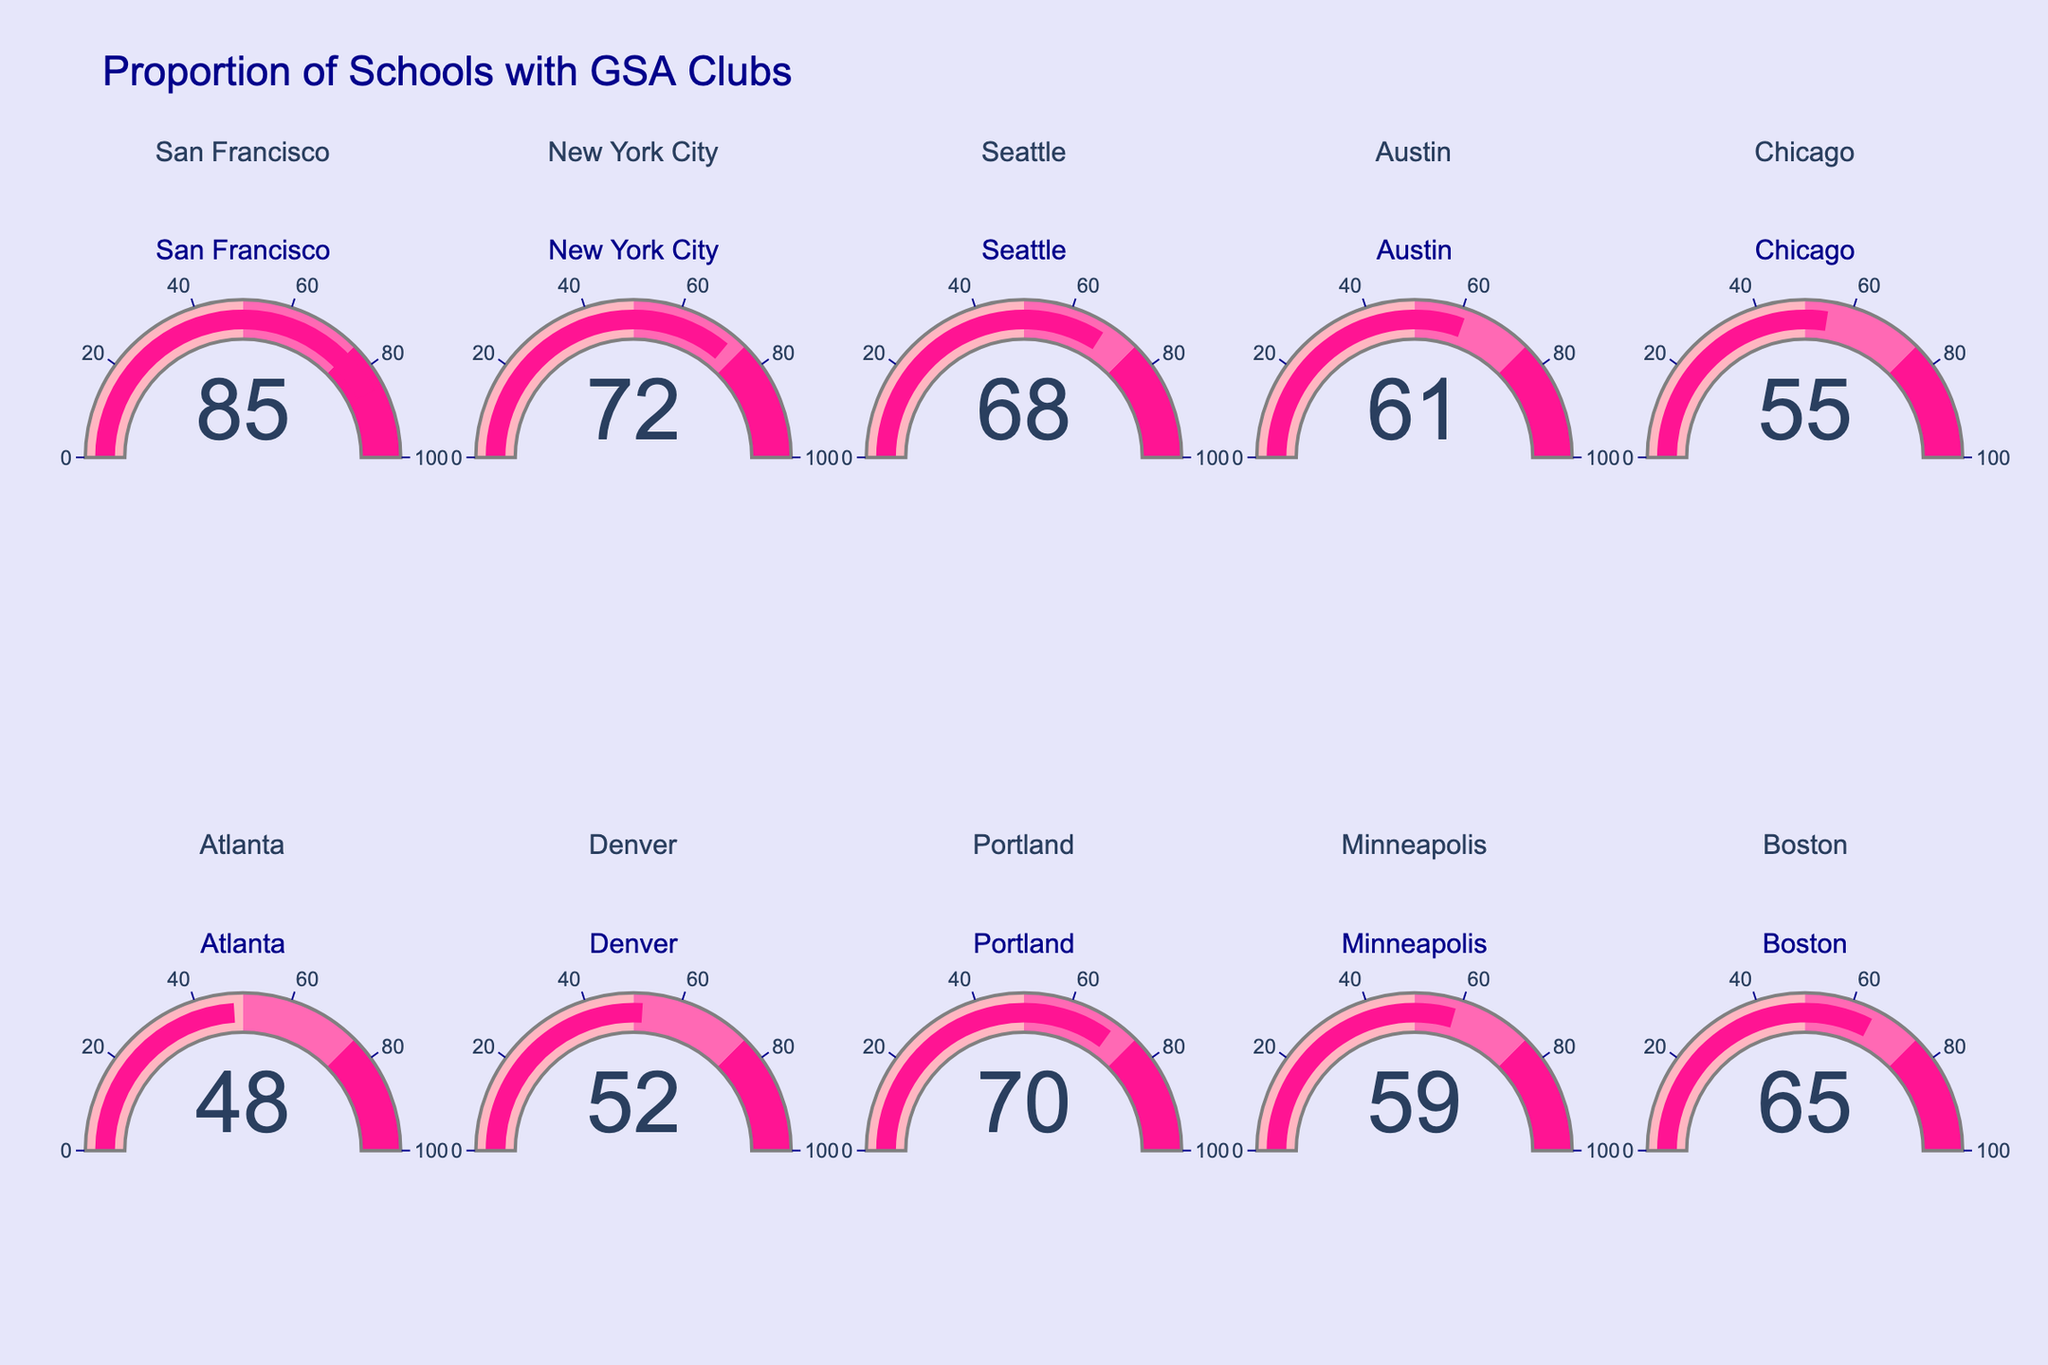Which city has the highest percentage of schools with GSA clubs? Look at all the gauges and identify the one with the highest percentage value displayed. San Francisco has the highest percentage with 85%.
Answer: San Francisco What's the lowest percentage of schools with GSA clubs, and which city does it belong to? Scan all the gauges to find the lowest percentage value. The lowest value is 48%, which belongs to Atlanta.
Answer: 48%, Atlanta What's the average percentage of schools with GSA clubs across all cities? Sum all the percentages from each gauge and divide by the number of cities (10). The sum is 85+72+68+61+55+48+52+70+59+65 = 635. The average is 635/10 = 63.5.
Answer: 63.5 How many cities have more than 60% of schools with GSA clubs? Count the number of gauges displaying values greater than 60%. The cities are San Francisco, New York City, Seattle, Portland, Boston. So, there are 5.
Answer: 5 Which cities have a percentage of schools with GSA clubs in the range 50-75%? Identify all gauges with values between 50 and 75 inclusive. These cities are New York City, Seattle, Austin, Chicago, Denver, Portland, Minneapolis, Boston.
Answer: New York City, Seattle, Austin, Chicago, Denver, Portland, Minneapolis, Boston What's the total number of cities surveyed in this figure? Count the total number of gauges to determine the number of cities surveyed. There are 10 gauges, one for each city.
Answer: 10 What's the difference in the proportion of schools with GSA clubs between San Francisco and Denver? Find the values for San Francisco (85%) and Denver (52%) and then subtract the smaller from the larger: 85 - 52 = 33.
Answer: 33 What is the color pattern used in the gauge chart steps? Observe the color of the gauge bar and steps. The colors are light pink (0-50), hot pink (50-75), and deeppink (75-100).
Answer: light pink, hot pink, deeppink Which cities fall into the 'hotpink' color range of 50-75% for their GSA percentage? Identify the cities whose gauges display values within the 50-75% range, marked by the hot pink color. These cities are New York City, Seattle, Austin, Chicago, Denver, Portland, Minneapolis, Boston.
Answer: New York City, Seattle, Austin, Chicago, Denver, Portland, Minneapolis, Boston 